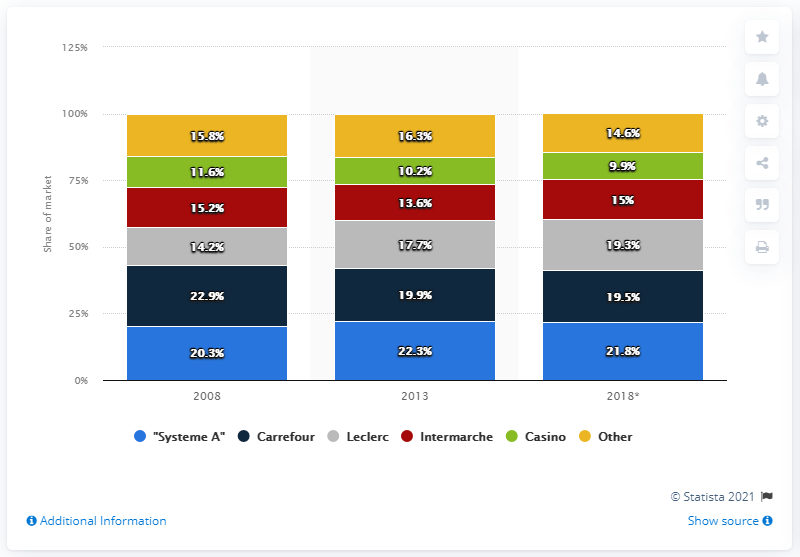Give some essential details in this illustration. Leclerc's market share is projected to increase to 19.3% in 2018. According to a recent survey, Carrefour has been named the most valuable French food brand. 